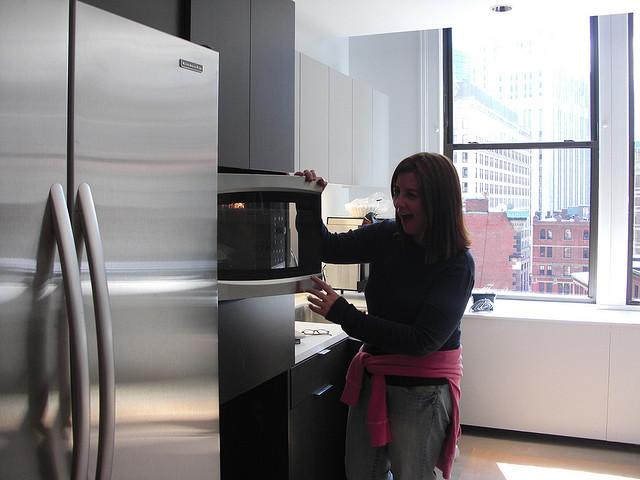What is the woman opening?
Short answer required. Microwave. What is around the woman's waist?
Quick response, please. Sweater. Does she live in a bungalow?
Short answer required. No. 